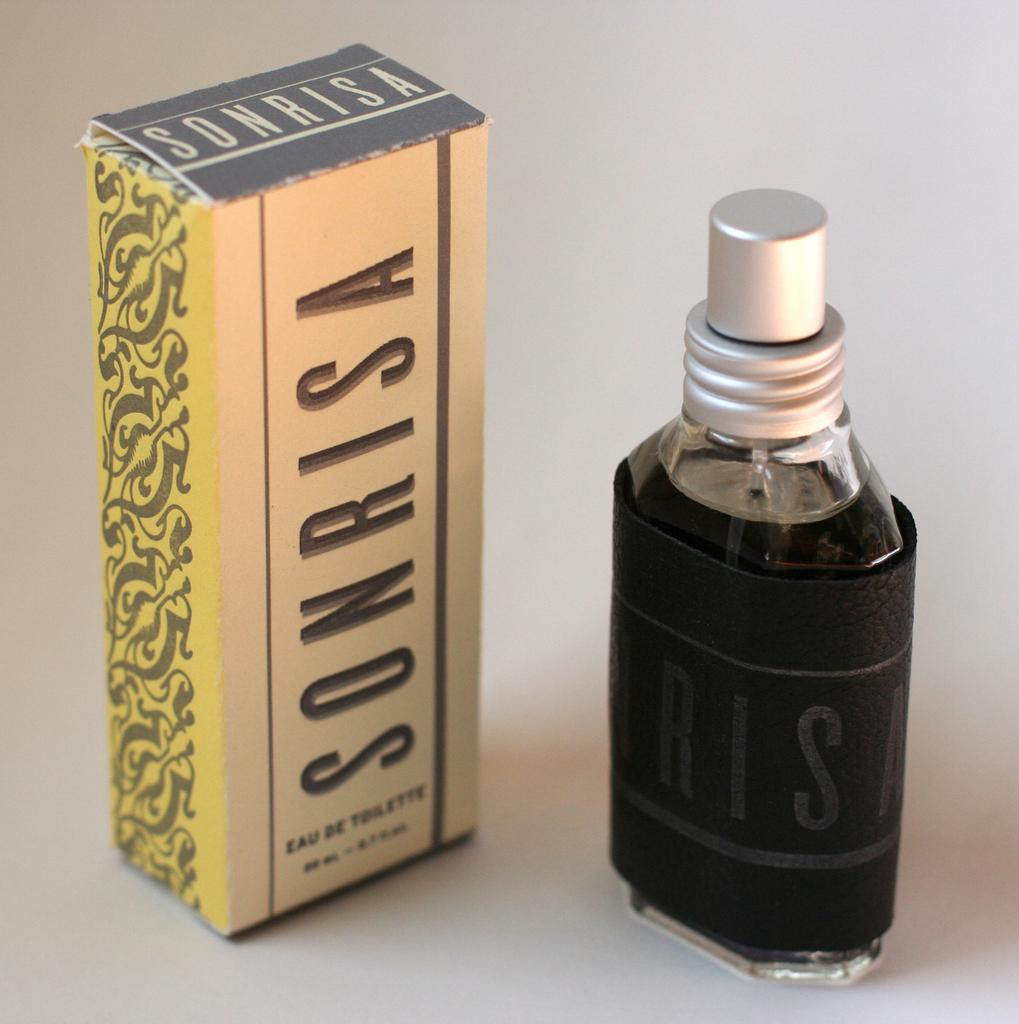What is covered by a black color sheet in the image? There is a bottle covered with a black color sheet in the image. What can be seen on the left side of the image? There is a box with cream, gold, and grey colors on the left side of the image. How many insects can be seen crawling on the bulb in the image? There are no insects or bulbs present in the image. Are there any children playing with the box in the image? There are no children present in the image. 